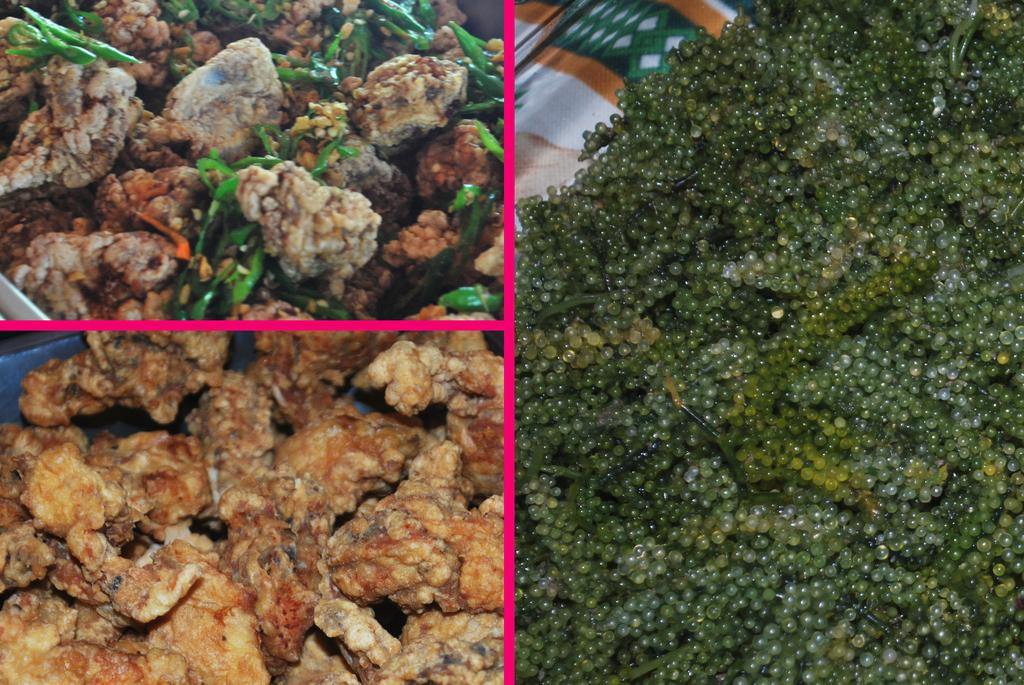What type of food items can be seen in the image? There are fruits, nuts, and meat items in the image. Can you describe the different food groups present in the image? The image contains fruits, nuts, and meat items, which represent different food groups. How can you tell that the image has been edited? The image appears to be edited, as the colors or arrangement of the food items may not be natural or realistic. What type of engine can be seen in the image? There is no engine present in the image; it contains food items such as fruits, nuts, and meat items. How many bricks are visible in the image? There are no bricks present in the image; it features food items and does not contain any building materials. 